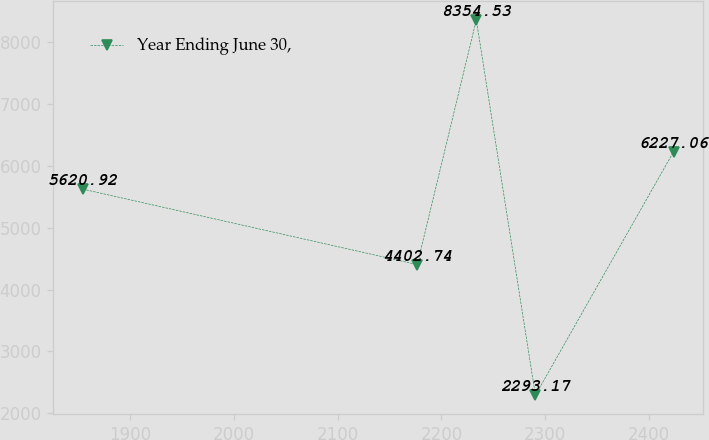Convert chart to OTSL. <chart><loc_0><loc_0><loc_500><loc_500><line_chart><ecel><fcel>Year Ending June 30,<nl><fcel>1854.57<fcel>5620.92<nl><fcel>2176.63<fcel>4402.74<nl><fcel>2233.53<fcel>8354.53<nl><fcel>2290.43<fcel>2293.17<nl><fcel>2423.57<fcel>6227.06<nl></chart> 